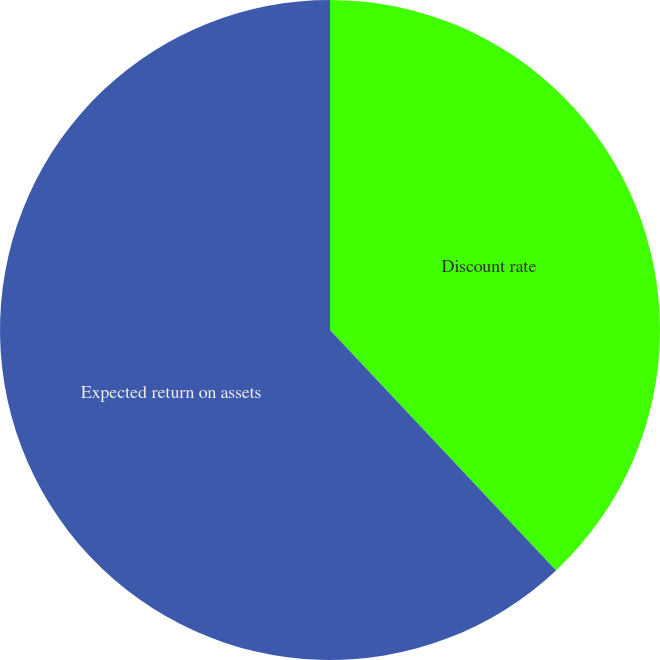<chart> <loc_0><loc_0><loc_500><loc_500><pie_chart><fcel>Discount rate<fcel>Expected return on assets<nl><fcel>37.99%<fcel>62.01%<nl></chart> 